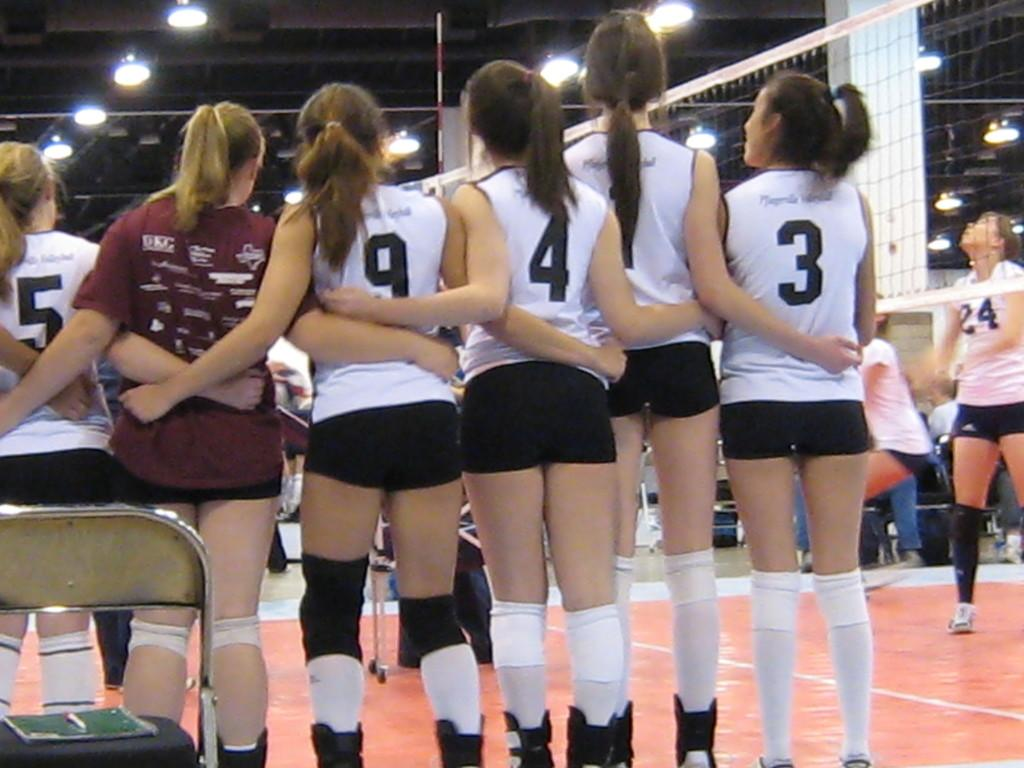<image>
Present a compact description of the photo's key features. 5,9,4 and 3 read the numbers of these volleyball players lining up for a photo. 